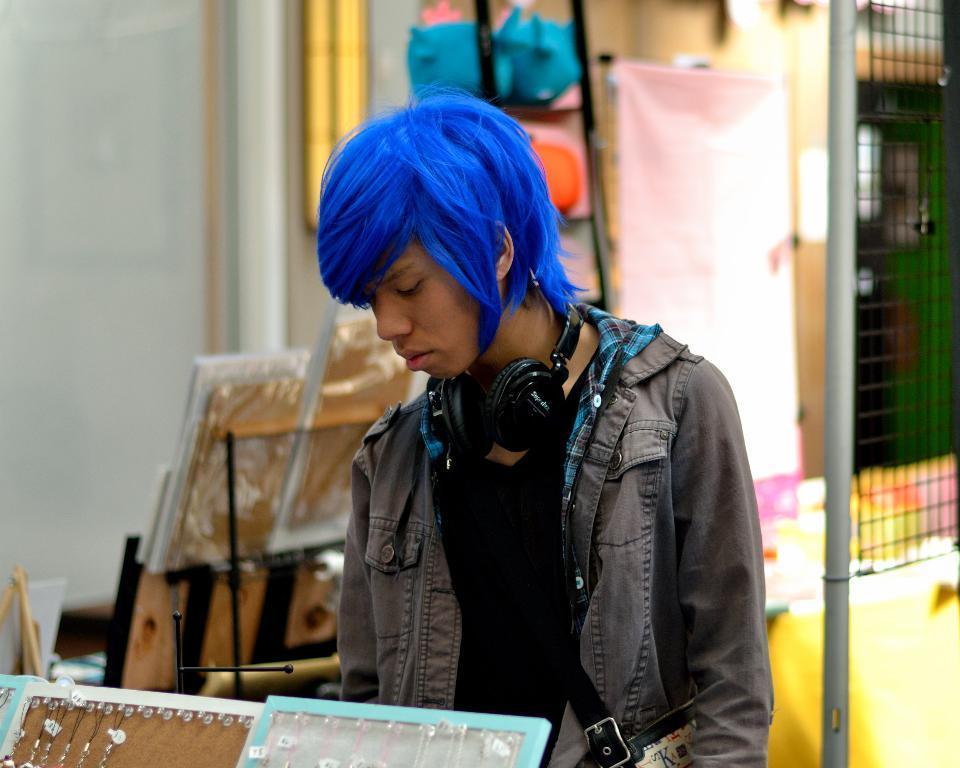How would you summarize this image in a sentence or two? This picture seems to be clicked inside. In the foreground we can see there are some objects. In the center there is a person wearing jacket and standing on the ground. In the background we can see the wall, metal rods, mesh and some other objects. 